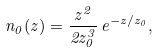Convert formula to latex. <formula><loc_0><loc_0><loc_500><loc_500>n _ { 0 } ( z ) = \frac { z ^ { 2 } } { 2 z _ { 0 } ^ { 3 } } \, e ^ { - z / z _ { 0 } } ,</formula> 